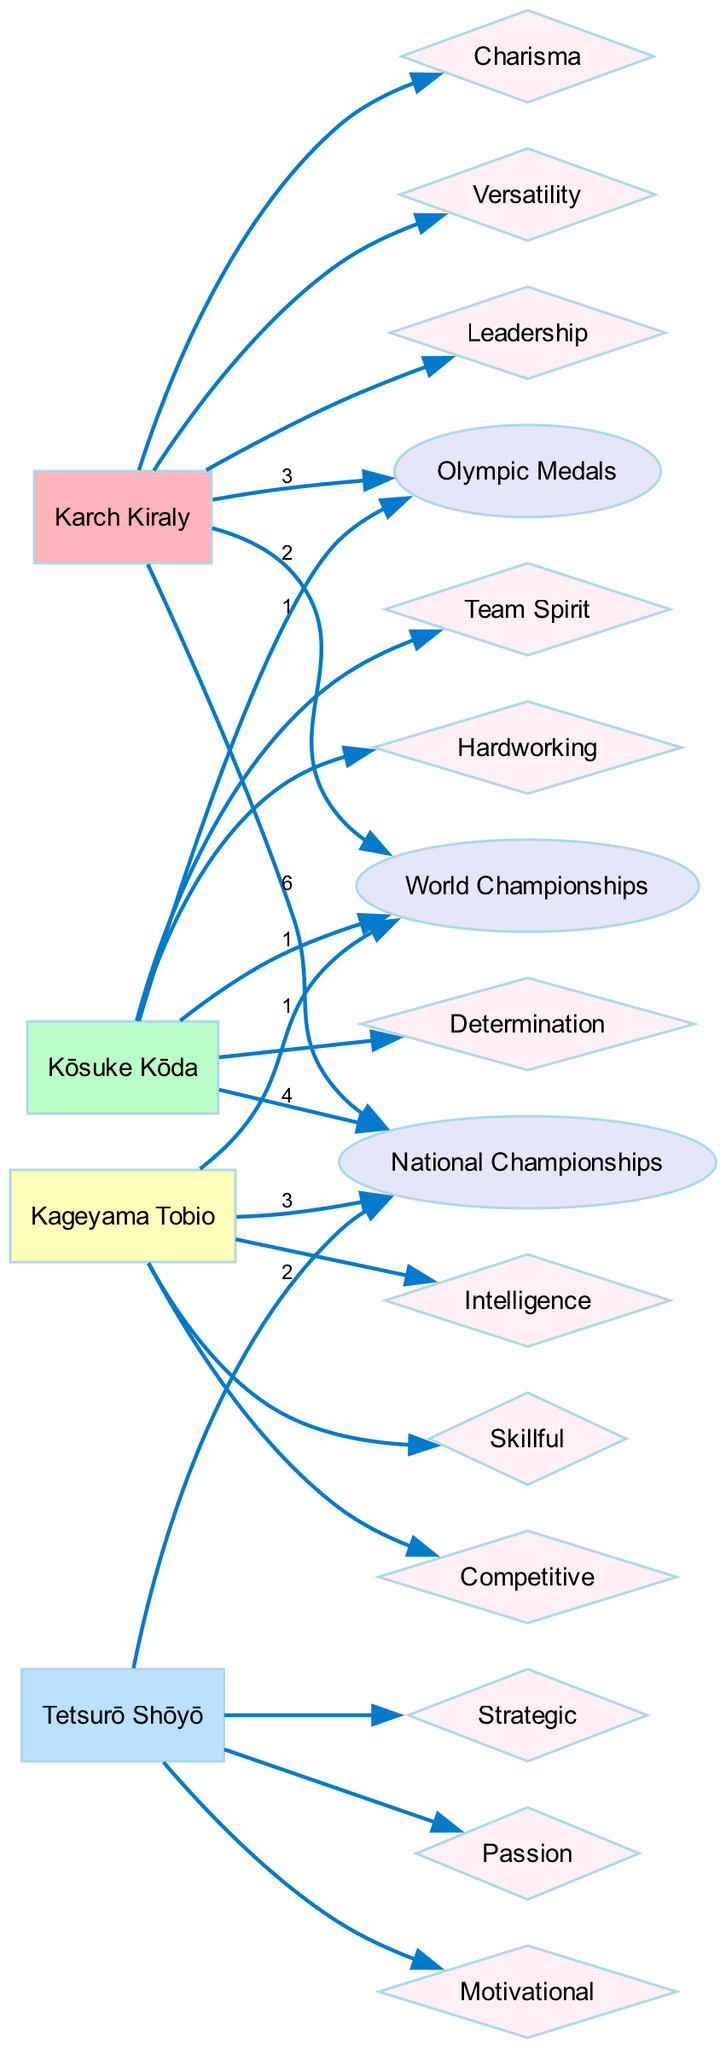What is the total number of Olympic medals won by Karch Kiraly? The diagram shows that Karch Kiraly has 3 Olympic medals listed next to his name.
Answer: 3 Which player has the highest number of National Championships? By examining the connections in the diagram, it is clear that Karch Kiraly has the highest value, with 6 National Championships.
Answer: Karch Kiraly How many different traits are attributed to Kōsuke Kōda? The diagram lists three traits connected to Kōsuke Kōda, which include Determination, Team Spirit, and Hardworking.
Answer: 3 Which statistic shows Kageyama Tobio's highest achievement? The flow from Kageyama Tobio's name to the World Championships indicates that he has 1 World Championship, which is his highest achievement.
Answer: 1 World Championship How many edges lead from Tetsurō Shōyō to traits? Counting the edges connected to Tetsurō Shōyō, we find that there are three edges leading to the traits Passion, Motivational, and Strategic.
Answer: 3 Which player has the trait 'Charisma'? The diagram shows that only Karch Kiraly is connected to the trait 'Charisma', making him the player associated with that trait.
Answer: Karch Kiraly Are there any players with zero Olympic medals? By analyzing the diagram, both Tetsurō Shōyō and Kageyama Tobio have zero Olympic medals indicated, confirming there are two players without any.
Answer: Yes What is the total number of National Championships represented in the diagram? Adding the values for National Championships from all players, we have 6 + 4 + 2 + 3, totaling 15 National Championships represented in the diagram.
Answer: 15 How many different statistics are compared in this diagram? The diagram indicates that there are three distinct statistics: Olympic Medals, World Championships, and National Championships being compared.
Answer: 3 